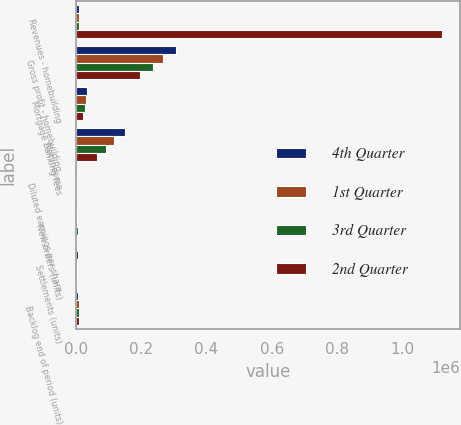Convert chart to OTSL. <chart><loc_0><loc_0><loc_500><loc_500><stacked_bar_chart><ecel><fcel>Revenues - homebuilding<fcel>Gross profit - homebuilding<fcel>Mortgage banking fees<fcel>Net income<fcel>Diluted earnings per share<fcel>New orders (units)<fcel>Settlements (units)<fcel>Backlog end of period (units)<nl><fcel>4th Quarter<fcel>7658<fcel>305087<fcel>34239<fcel>150891<fcel>37.8<fcel>3645<fcel>4419<fcel>6884<nl><fcel>1st Quarter<fcel>7658<fcel>265159<fcel>30118<fcel>117392<fcel>28.46<fcel>3477<fcel>3922<fcel>7658<nl><fcel>3rd Quarter<fcel>7658<fcel>235372<fcel>26442<fcel>91676<fcel>22.01<fcel>4324<fcel>3581<fcel>8103<nl><fcel>2nd Quarter<fcel>1.1215e+06<fcel>195744<fcel>22522<fcel>65303<fcel>15.79<fcel>4137<fcel>3006<fcel>7360<nl></chart> 